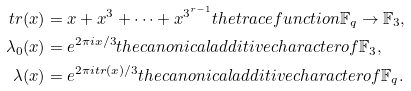Convert formula to latex. <formula><loc_0><loc_0><loc_500><loc_500>t r ( x ) & = x + x ^ { 3 } + \cdots + x ^ { 3 ^ { r - 1 } } t h e t r a c e f u n c t i o n \mathbb { F } _ { q } \rightarrow \mathbb { F } _ { 3 } , \\ \lambda _ { 0 } ( x ) & = e ^ { 2 \pi i x / 3 } t h e c a n o n i c a l a d d i t i v e c h a r a c t e r o f \mathbb { F } _ { 3 } , \\ \lambda ( x ) & = e ^ { 2 \pi i t r ( x ) / 3 } t h e c a n o n i c a l a d d i t i v e c h a r a c t e r o f \mathbb { F } _ { q } .</formula> 